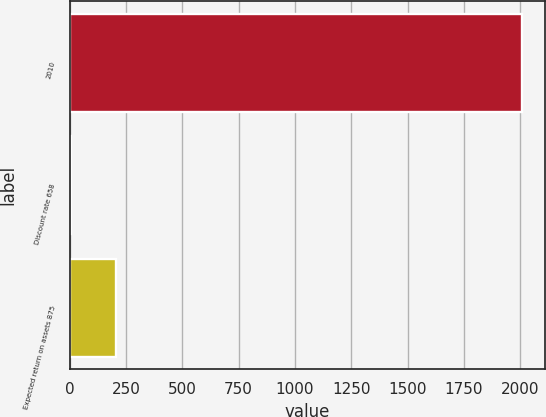Convert chart. <chart><loc_0><loc_0><loc_500><loc_500><bar_chart><fcel>2010<fcel>Discount rate 658<fcel>Expected return on assets 875<nl><fcel>2008<fcel>6.25<fcel>206.43<nl></chart> 